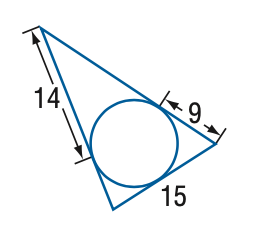Answer the mathemtical geometry problem and directly provide the correct option letter.
Question: Find the perimeter of the triangle at the right. Assume that segments that appear to be tangent are tangent.
Choices: A: 29 B: 38 C: 58 D: 76 C 